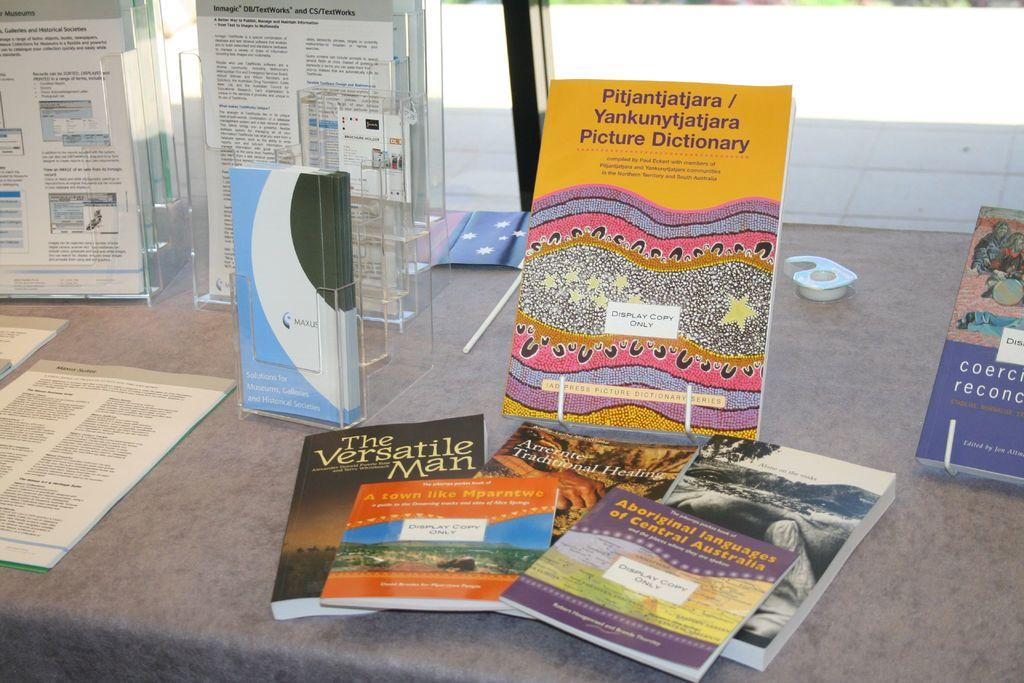<image>
Write a terse but informative summary of the picture. a variety of magazines and one titled the versatile man 